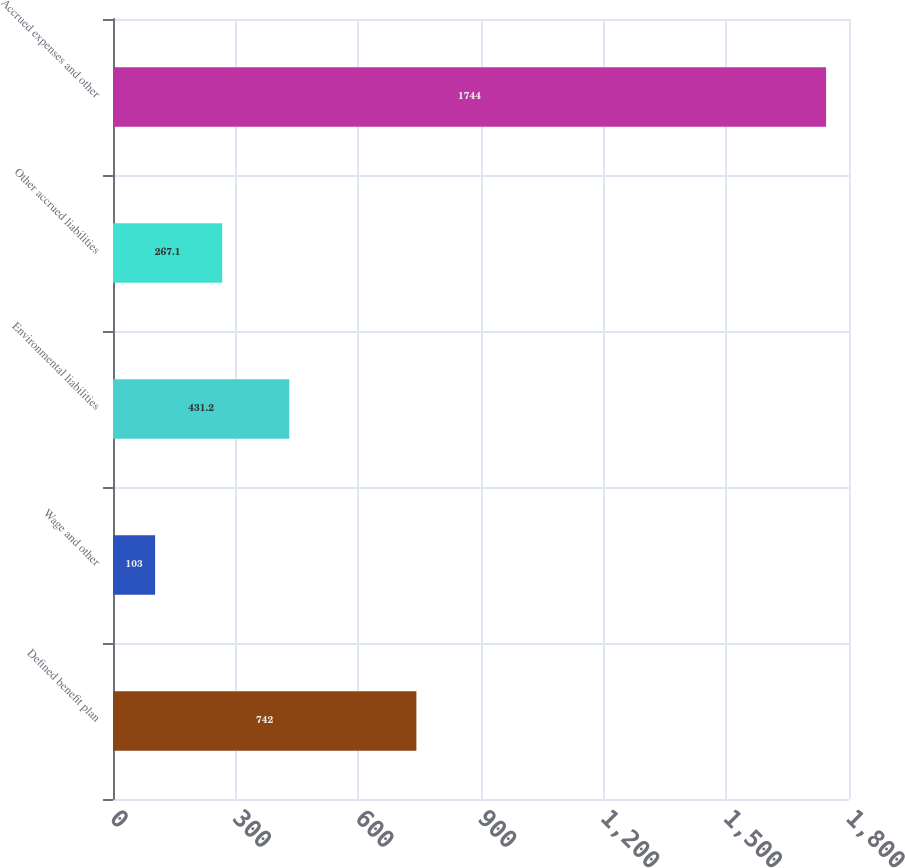Convert chart. <chart><loc_0><loc_0><loc_500><loc_500><bar_chart><fcel>Defined benefit plan<fcel>Wage and other<fcel>Environmental liabilities<fcel>Other accrued liabilities<fcel>Accrued expenses and other<nl><fcel>742<fcel>103<fcel>431.2<fcel>267.1<fcel>1744<nl></chart> 